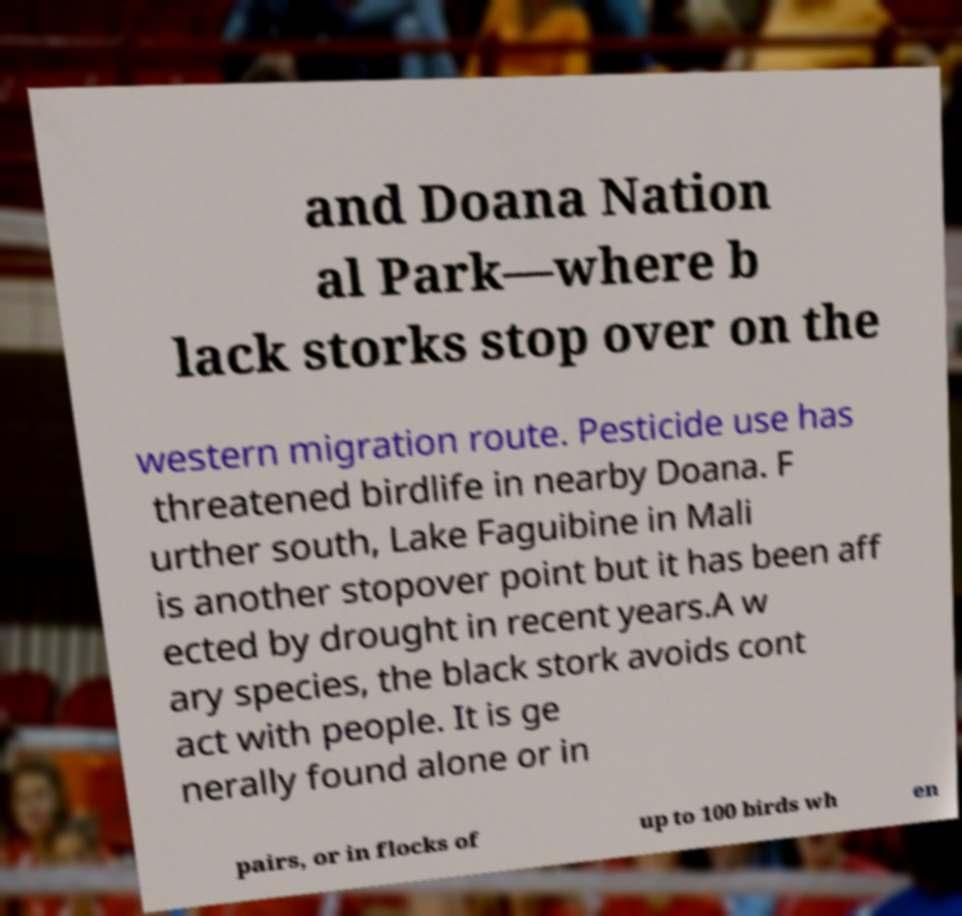Could you assist in decoding the text presented in this image and type it out clearly? and Doana Nation al Park—where b lack storks stop over on the western migration route. Pesticide use has threatened birdlife in nearby Doana. F urther south, Lake Faguibine in Mali is another stopover point but it has been aff ected by drought in recent years.A w ary species, the black stork avoids cont act with people. It is ge nerally found alone or in pairs, or in flocks of up to 100 birds wh en 